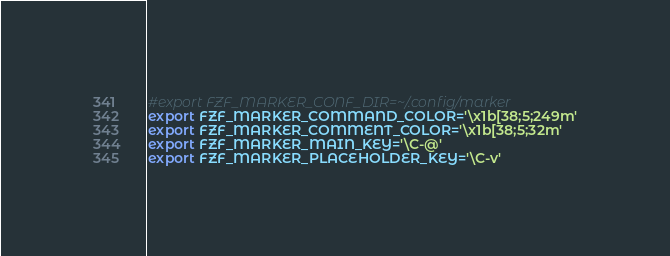Convert code to text. <code><loc_0><loc_0><loc_500><loc_500><_Bash_>#export FZF_MARKER_CONF_DIR=~/.config/marker
export FZF_MARKER_COMMAND_COLOR='\x1b[38;5;249m'
export FZF_MARKER_COMMENT_COLOR='\x1b[38;5;32m'
export FZF_MARKER_MAIN_KEY='\C-@'
export FZF_MARKER_PLACEHOLDER_KEY='\C-v'
</code> 